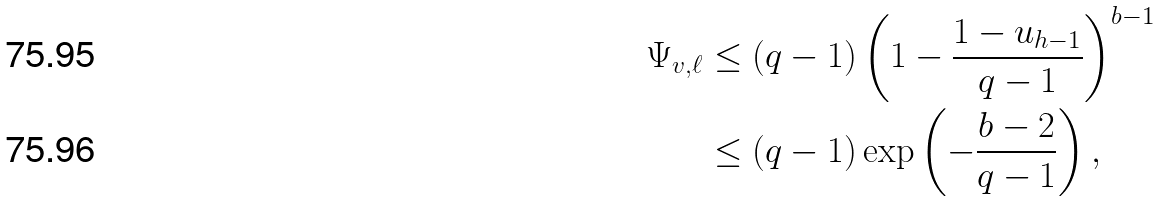Convert formula to latex. <formula><loc_0><loc_0><loc_500><loc_500>\Psi _ { v , \ell } & \leq ( q - 1 ) \left ( 1 - \frac { 1 - u _ { h - 1 } } { q - 1 } \right ) ^ { b - 1 } \\ & \leq ( q - 1 ) \exp \left ( - \frac { b - 2 } { q - 1 } \right ) ,</formula> 